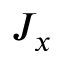<formula> <loc_0><loc_0><loc_500><loc_500>J _ { x }</formula> 